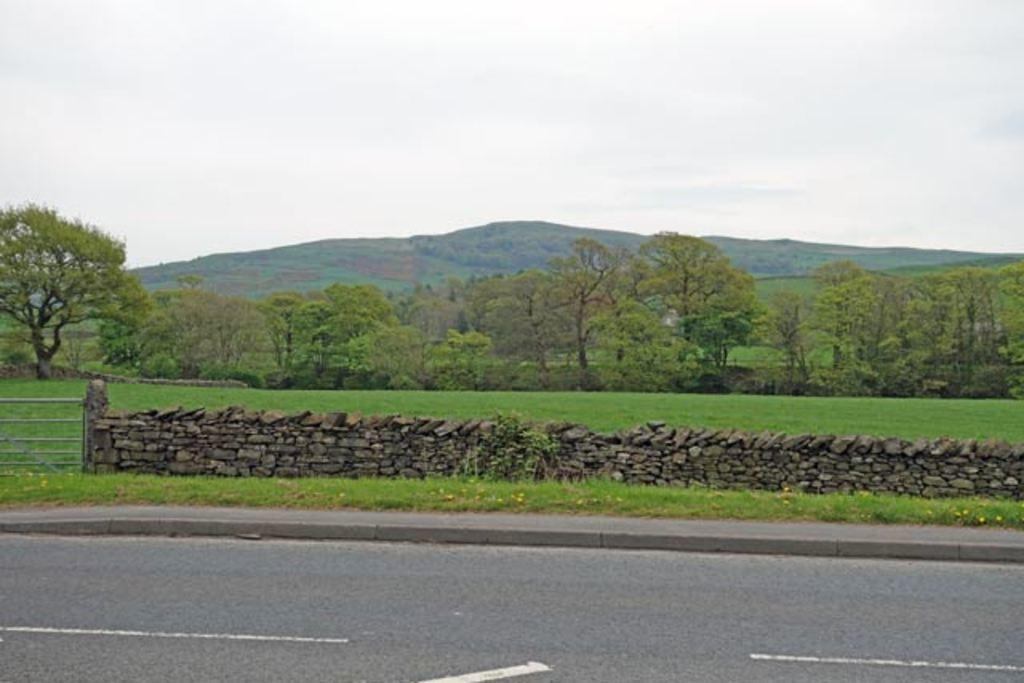Please provide a concise description of this image. This image is taken outdoors. At the bottom of the image there is a road. At the top of the image there is a sky with clouds. In the middle of the image there is a hill and there are many plants and trees on the ground and there is a ground with grass on it. There is a wall with many stones and there is a railing. 